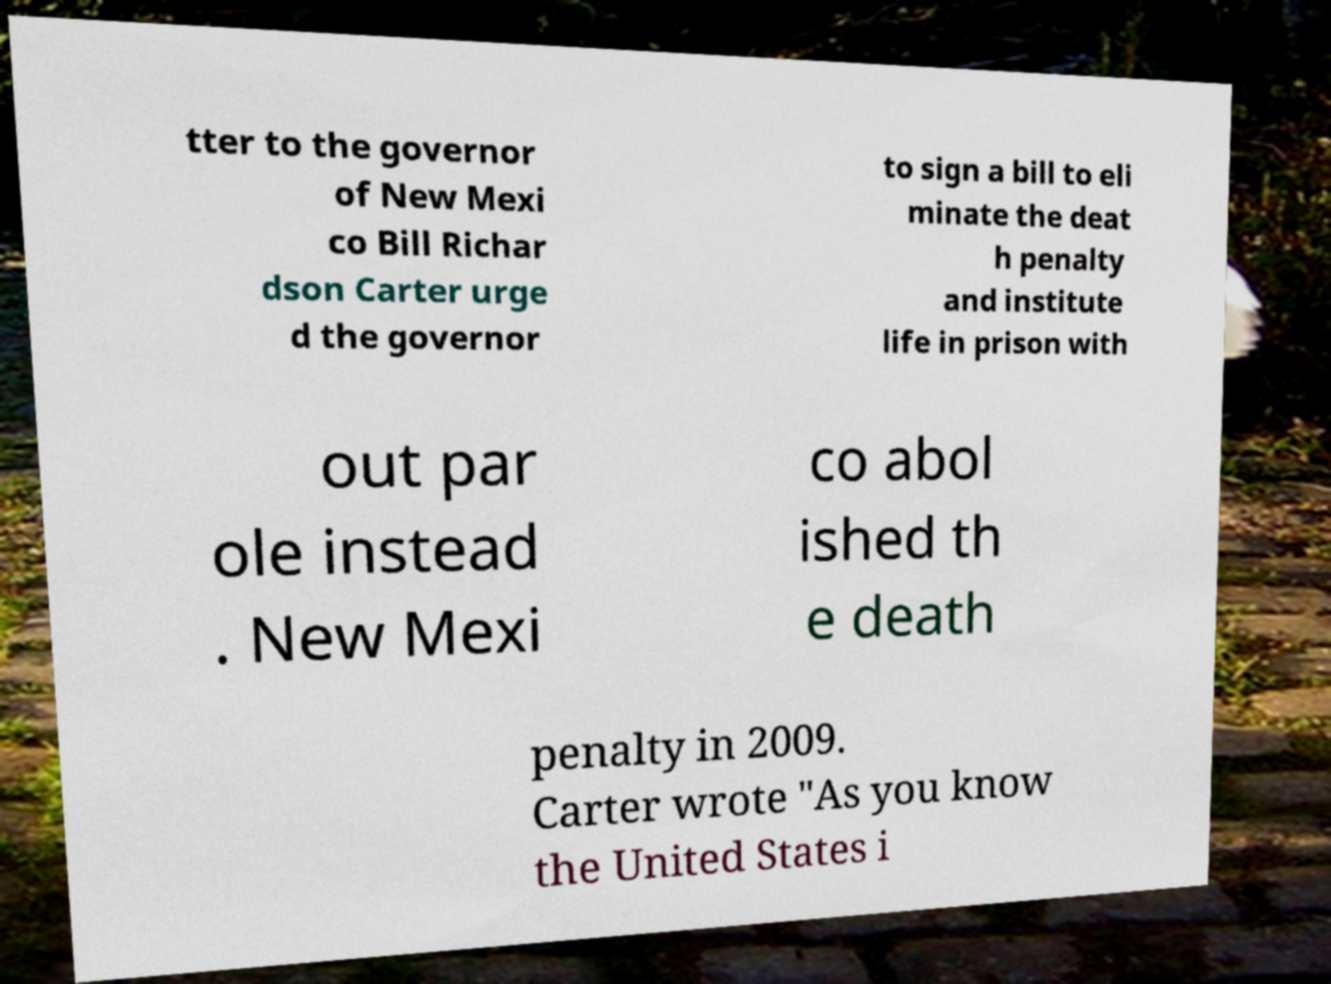There's text embedded in this image that I need extracted. Can you transcribe it verbatim? tter to the governor of New Mexi co Bill Richar dson Carter urge d the governor to sign a bill to eli minate the deat h penalty and institute life in prison with out par ole instead . New Mexi co abol ished th e death penalty in 2009. Carter wrote "As you know the United States i 